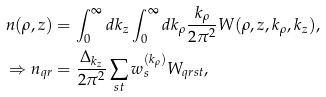Convert formula to latex. <formula><loc_0><loc_0><loc_500><loc_500>n ( \rho , z ) & = \int _ { 0 } ^ { \infty } d { k _ { z } } \int _ { 0 } ^ { \infty } d k _ { \rho } \frac { k _ { \rho } } { 2 \pi ^ { 2 } } W ( \rho , z , k _ { \rho } , k _ { z } ) , \\ \Rightarrow n _ { q r } & = \frac { \Delta _ { k _ { z } } } { 2 \pi ^ { 2 } } \sum _ { s t } w _ { s } ^ { ( k _ { \rho } ) } W _ { q r s t } ,</formula> 